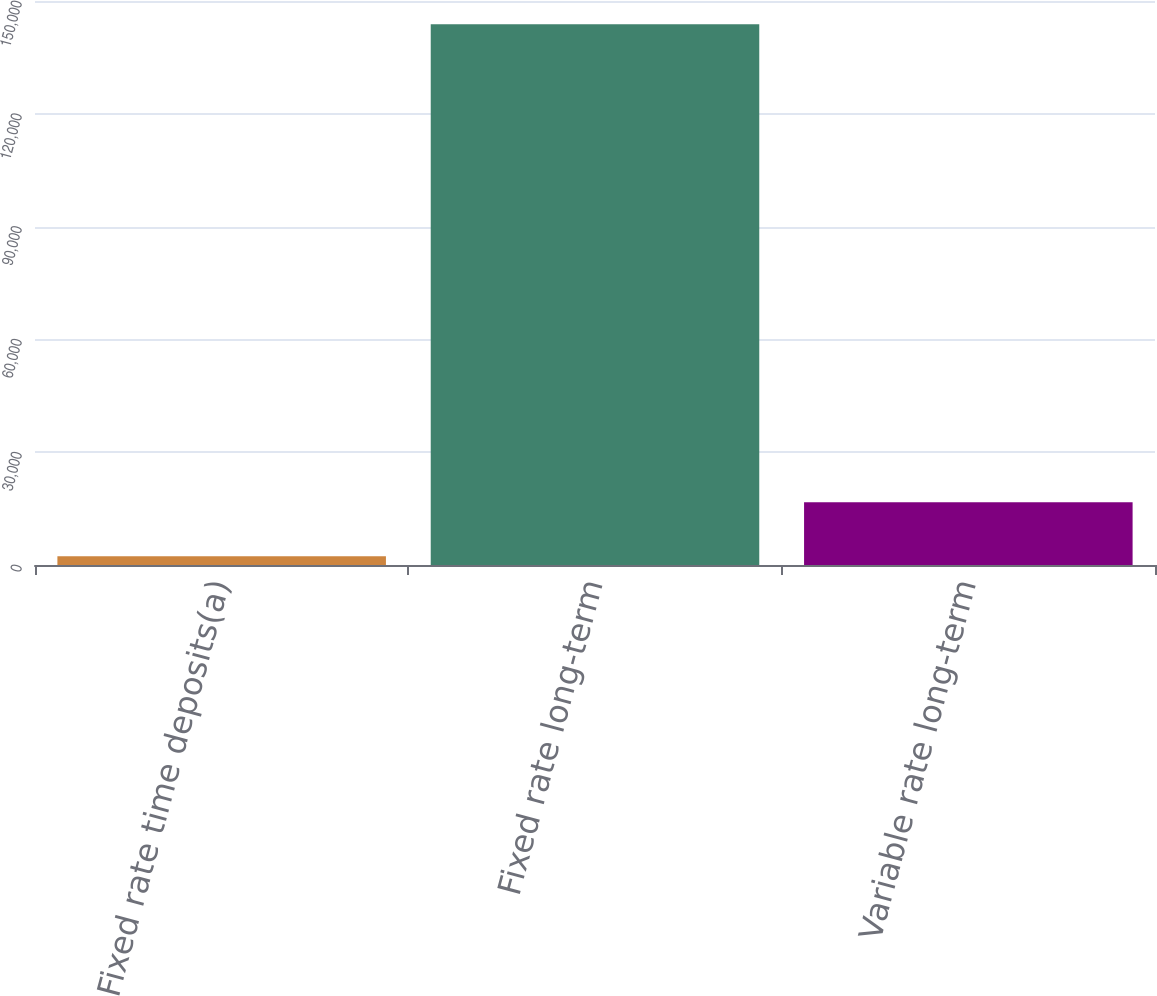Convert chart. <chart><loc_0><loc_0><loc_500><loc_500><bar_chart><fcel>Fixed rate time deposits(a)<fcel>Fixed rate long-term<fcel>Variable rate long-term<nl><fcel>2300<fcel>143811<fcel>16690<nl></chart> 